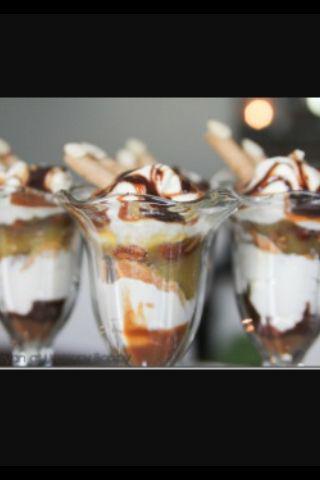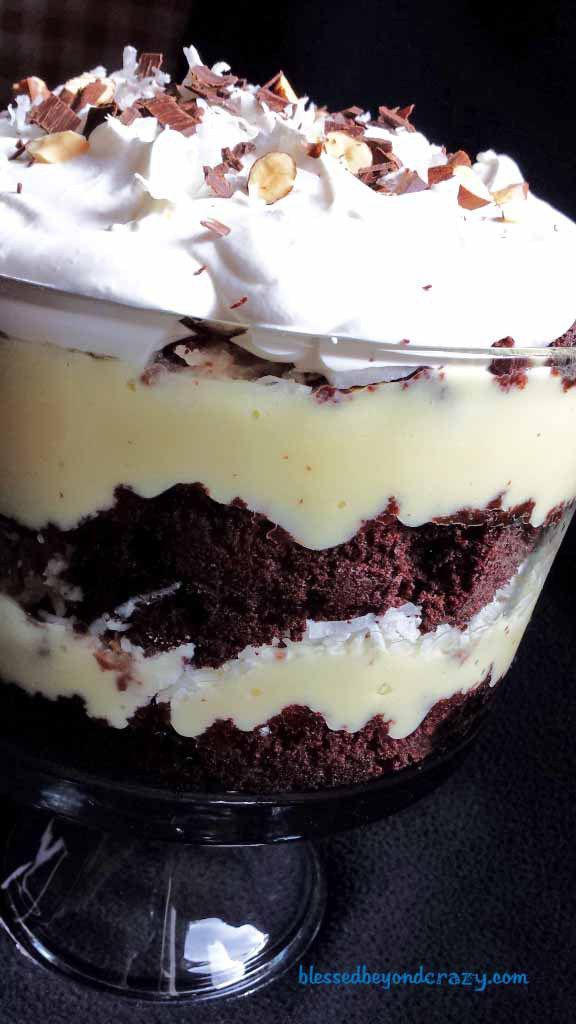The first image is the image on the left, the second image is the image on the right. Evaluate the accuracy of this statement regarding the images: "There are three cups of dessert in the image on the left.". Is it true? Answer yes or no. Yes. 